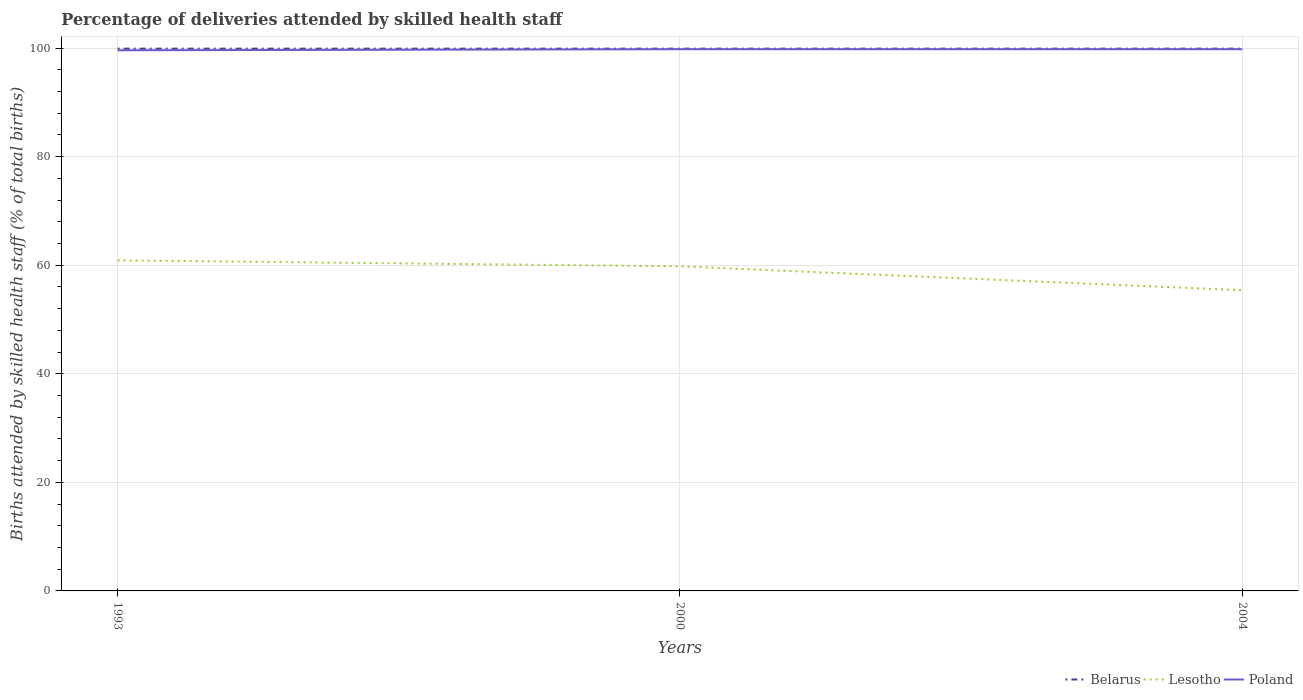Does the line corresponding to Poland intersect with the line corresponding to Lesotho?
Keep it short and to the point. No. Across all years, what is the maximum percentage of births attended by skilled health staff in Lesotho?
Make the answer very short. 55.4. What is the total percentage of births attended by skilled health staff in Lesotho in the graph?
Your answer should be very brief. 1.1. What is the difference between the highest and the second highest percentage of births attended by skilled health staff in Belarus?
Offer a very short reply. 0. What is the difference between the highest and the lowest percentage of births attended by skilled health staff in Lesotho?
Give a very brief answer. 2. Is the percentage of births attended by skilled health staff in Poland strictly greater than the percentage of births attended by skilled health staff in Belarus over the years?
Provide a short and direct response. Yes. Does the graph contain grids?
Ensure brevity in your answer.  Yes. Where does the legend appear in the graph?
Offer a terse response. Bottom right. How many legend labels are there?
Your answer should be compact. 3. What is the title of the graph?
Provide a succinct answer. Percentage of deliveries attended by skilled health staff. Does "Benin" appear as one of the legend labels in the graph?
Provide a succinct answer. No. What is the label or title of the X-axis?
Make the answer very short. Years. What is the label or title of the Y-axis?
Ensure brevity in your answer.  Births attended by skilled health staff (% of total births). What is the Births attended by skilled health staff (% of total births) in Belarus in 1993?
Ensure brevity in your answer.  99.9. What is the Births attended by skilled health staff (% of total births) of Lesotho in 1993?
Your answer should be compact. 60.9. What is the Births attended by skilled health staff (% of total births) in Poland in 1993?
Ensure brevity in your answer.  99.6. What is the Births attended by skilled health staff (% of total births) of Belarus in 2000?
Your answer should be compact. 99.9. What is the Births attended by skilled health staff (% of total births) of Lesotho in 2000?
Make the answer very short. 59.8. What is the Births attended by skilled health staff (% of total births) of Poland in 2000?
Make the answer very short. 99.8. What is the Births attended by skilled health staff (% of total births) in Belarus in 2004?
Offer a terse response. 99.9. What is the Births attended by skilled health staff (% of total births) in Lesotho in 2004?
Your answer should be very brief. 55.4. What is the Births attended by skilled health staff (% of total births) in Poland in 2004?
Provide a succinct answer. 99.8. Across all years, what is the maximum Births attended by skilled health staff (% of total births) of Belarus?
Make the answer very short. 99.9. Across all years, what is the maximum Births attended by skilled health staff (% of total births) of Lesotho?
Make the answer very short. 60.9. Across all years, what is the maximum Births attended by skilled health staff (% of total births) in Poland?
Give a very brief answer. 99.8. Across all years, what is the minimum Births attended by skilled health staff (% of total births) in Belarus?
Provide a succinct answer. 99.9. Across all years, what is the minimum Births attended by skilled health staff (% of total births) in Lesotho?
Your response must be concise. 55.4. Across all years, what is the minimum Births attended by skilled health staff (% of total births) in Poland?
Ensure brevity in your answer.  99.6. What is the total Births attended by skilled health staff (% of total births) in Belarus in the graph?
Offer a terse response. 299.7. What is the total Births attended by skilled health staff (% of total births) of Lesotho in the graph?
Give a very brief answer. 176.1. What is the total Births attended by skilled health staff (% of total births) of Poland in the graph?
Provide a short and direct response. 299.2. What is the difference between the Births attended by skilled health staff (% of total births) in Lesotho in 1993 and that in 2000?
Your answer should be compact. 1.1. What is the difference between the Births attended by skilled health staff (% of total births) of Belarus in 2000 and that in 2004?
Offer a very short reply. 0. What is the difference between the Births attended by skilled health staff (% of total births) in Lesotho in 2000 and that in 2004?
Provide a short and direct response. 4.4. What is the difference between the Births attended by skilled health staff (% of total births) in Poland in 2000 and that in 2004?
Ensure brevity in your answer.  0. What is the difference between the Births attended by skilled health staff (% of total births) of Belarus in 1993 and the Births attended by skilled health staff (% of total births) of Lesotho in 2000?
Your answer should be very brief. 40.1. What is the difference between the Births attended by skilled health staff (% of total births) of Belarus in 1993 and the Births attended by skilled health staff (% of total births) of Poland in 2000?
Your answer should be very brief. 0.1. What is the difference between the Births attended by skilled health staff (% of total births) of Lesotho in 1993 and the Births attended by skilled health staff (% of total births) of Poland in 2000?
Your response must be concise. -38.9. What is the difference between the Births attended by skilled health staff (% of total births) of Belarus in 1993 and the Births attended by skilled health staff (% of total births) of Lesotho in 2004?
Your answer should be compact. 44.5. What is the difference between the Births attended by skilled health staff (% of total births) of Lesotho in 1993 and the Births attended by skilled health staff (% of total births) of Poland in 2004?
Make the answer very short. -38.9. What is the difference between the Births attended by skilled health staff (% of total births) in Belarus in 2000 and the Births attended by skilled health staff (% of total births) in Lesotho in 2004?
Your answer should be very brief. 44.5. What is the difference between the Births attended by skilled health staff (% of total births) of Belarus in 2000 and the Births attended by skilled health staff (% of total births) of Poland in 2004?
Ensure brevity in your answer.  0.1. What is the average Births attended by skilled health staff (% of total births) of Belarus per year?
Make the answer very short. 99.9. What is the average Births attended by skilled health staff (% of total births) of Lesotho per year?
Provide a short and direct response. 58.7. What is the average Births attended by skilled health staff (% of total births) of Poland per year?
Provide a short and direct response. 99.73. In the year 1993, what is the difference between the Births attended by skilled health staff (% of total births) of Belarus and Births attended by skilled health staff (% of total births) of Lesotho?
Provide a succinct answer. 39. In the year 1993, what is the difference between the Births attended by skilled health staff (% of total births) of Belarus and Births attended by skilled health staff (% of total births) of Poland?
Keep it short and to the point. 0.3. In the year 1993, what is the difference between the Births attended by skilled health staff (% of total births) in Lesotho and Births attended by skilled health staff (% of total births) in Poland?
Offer a very short reply. -38.7. In the year 2000, what is the difference between the Births attended by skilled health staff (% of total births) of Belarus and Births attended by skilled health staff (% of total births) of Lesotho?
Your answer should be very brief. 40.1. In the year 2000, what is the difference between the Births attended by skilled health staff (% of total births) of Belarus and Births attended by skilled health staff (% of total births) of Poland?
Offer a very short reply. 0.1. In the year 2004, what is the difference between the Births attended by skilled health staff (% of total births) in Belarus and Births attended by skilled health staff (% of total births) in Lesotho?
Offer a terse response. 44.5. In the year 2004, what is the difference between the Births attended by skilled health staff (% of total births) of Lesotho and Births attended by skilled health staff (% of total births) of Poland?
Offer a very short reply. -44.4. What is the ratio of the Births attended by skilled health staff (% of total births) of Lesotho in 1993 to that in 2000?
Make the answer very short. 1.02. What is the ratio of the Births attended by skilled health staff (% of total births) of Poland in 1993 to that in 2000?
Keep it short and to the point. 1. What is the ratio of the Births attended by skilled health staff (% of total births) of Lesotho in 1993 to that in 2004?
Keep it short and to the point. 1.1. What is the ratio of the Births attended by skilled health staff (% of total births) in Lesotho in 2000 to that in 2004?
Ensure brevity in your answer.  1.08. What is the ratio of the Births attended by skilled health staff (% of total births) in Poland in 2000 to that in 2004?
Provide a short and direct response. 1. What is the difference between the highest and the lowest Births attended by skilled health staff (% of total births) in Lesotho?
Give a very brief answer. 5.5. 